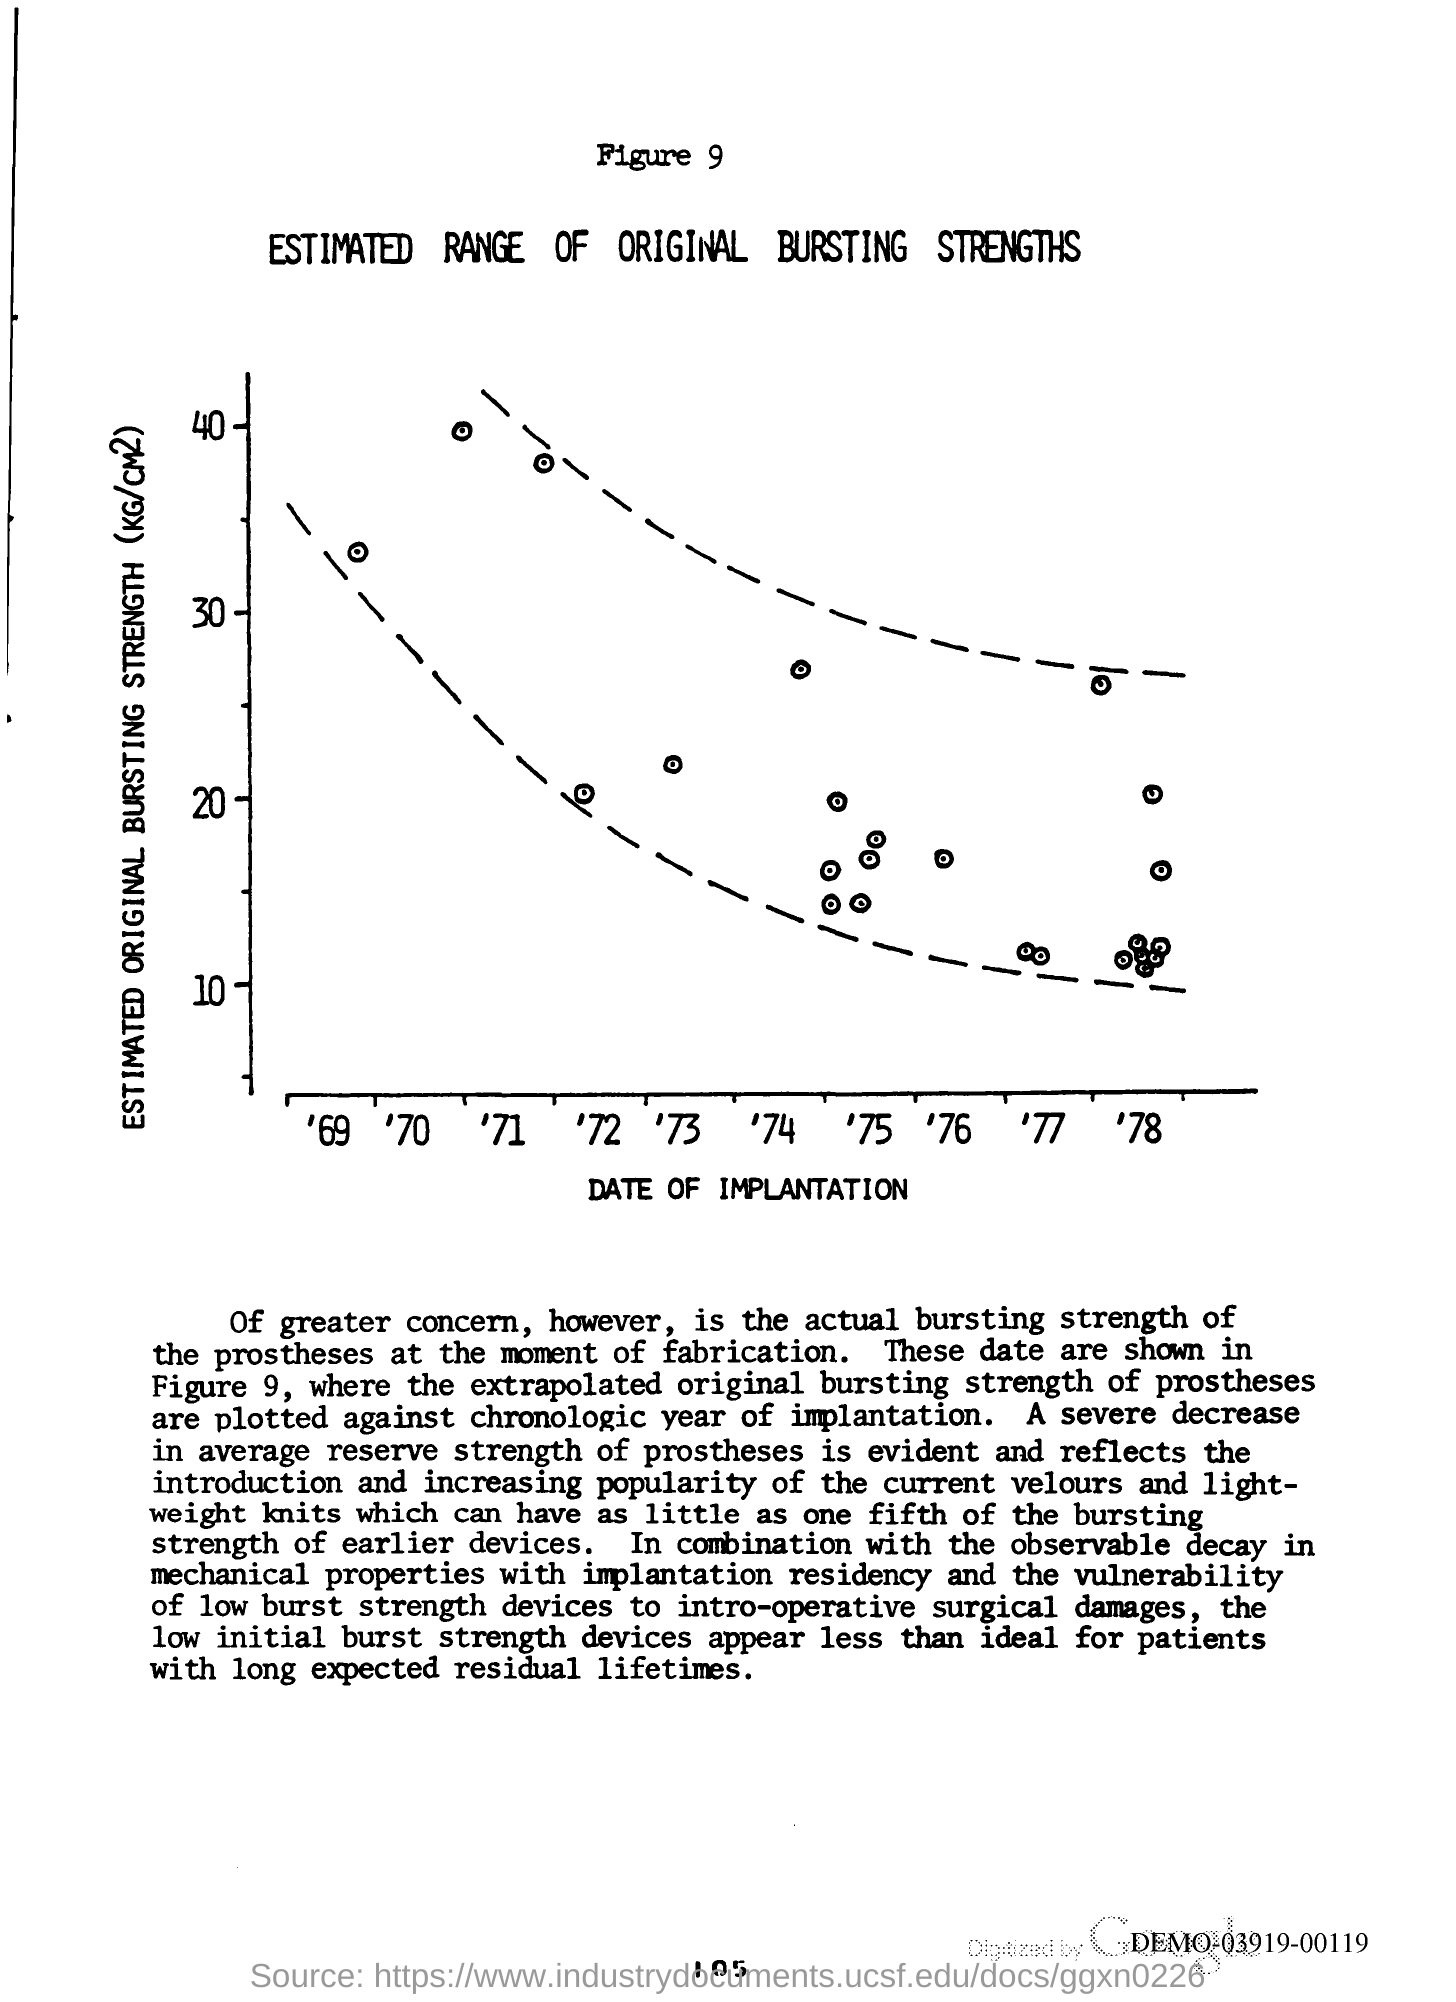Point out several critical features in this image. The y-axis of the graph represents the estimated original bursting strength, in kilograms per cubic centimeter. The title of Figure 9 is 'Estimated Range of Original Bursting Strengths.' The x-axis in the graph represents the date of implantation. 